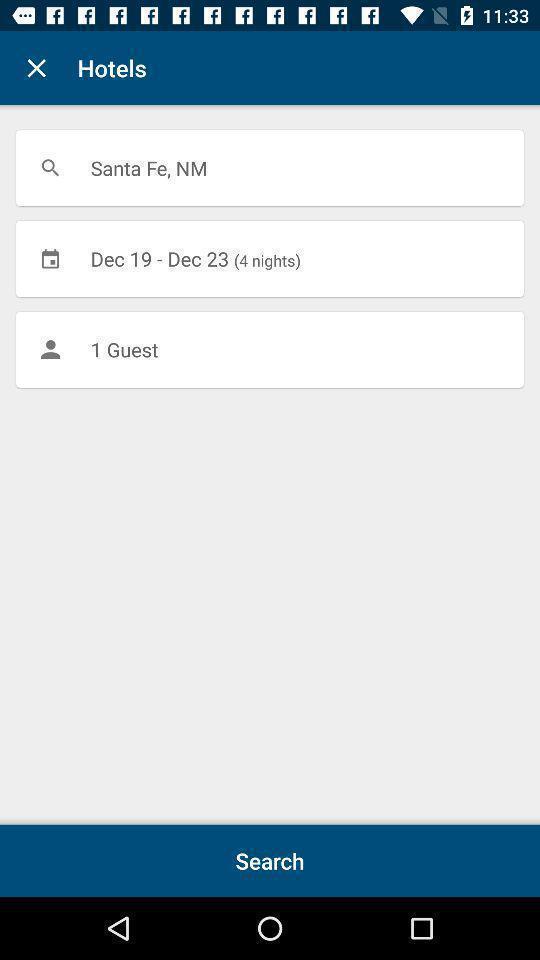Tell me what you see in this picture. Search page of hotels with date. 